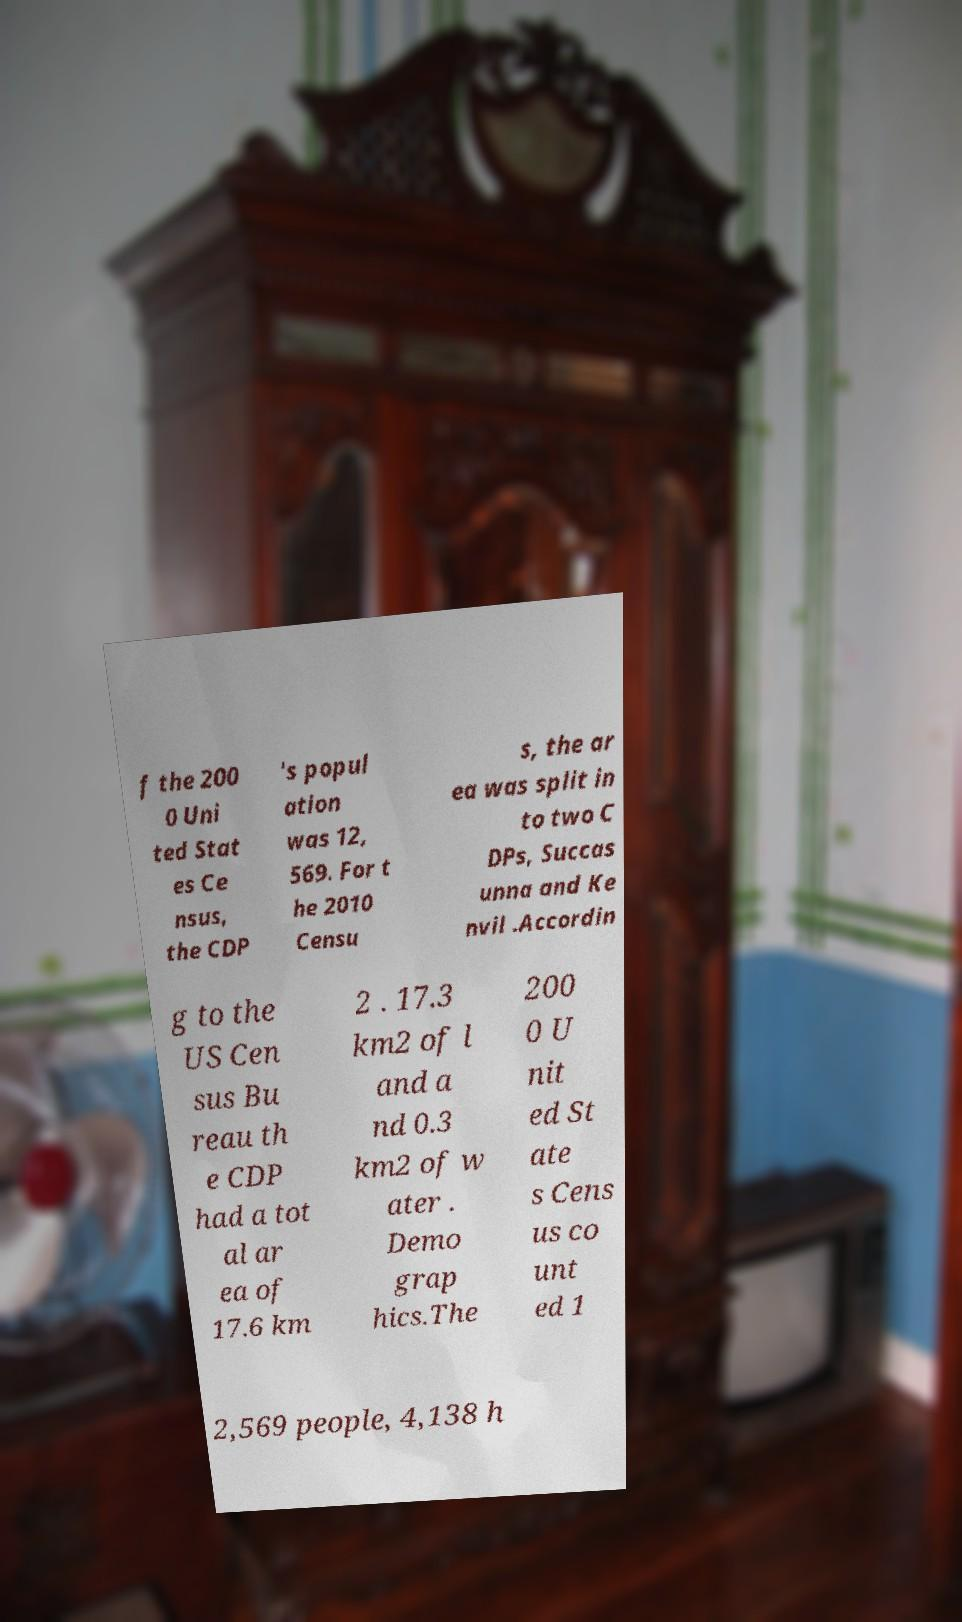I need the written content from this picture converted into text. Can you do that? f the 200 0 Uni ted Stat es Ce nsus, the CDP 's popul ation was 12, 569. For t he 2010 Censu s, the ar ea was split in to two C DPs, Succas unna and Ke nvil .Accordin g to the US Cen sus Bu reau th e CDP had a tot al ar ea of 17.6 km 2 . 17.3 km2 of l and a nd 0.3 km2 of w ater . Demo grap hics.The 200 0 U nit ed St ate s Cens us co unt ed 1 2,569 people, 4,138 h 